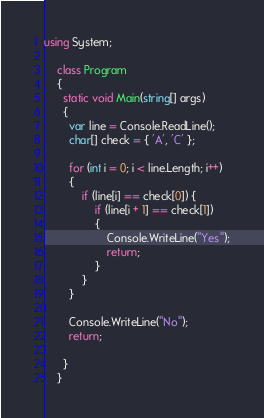<code> <loc_0><loc_0><loc_500><loc_500><_C#_>using System;

    class Program
    {
      static void Main(string[] args)
      {
        var line = Console.ReadLine();
        char[] check = { 'A', 'C' };

        for (int i = 0; i < line.Length; i++)
        {
            if (line[i] == check[0]) {
                if (line[i + 1] == check[1])
                {
                    Console.WriteLine("Yes");
                    return;
                }
            }
        }

        Console.WriteLine("No");
        return;

      }
    }</code> 